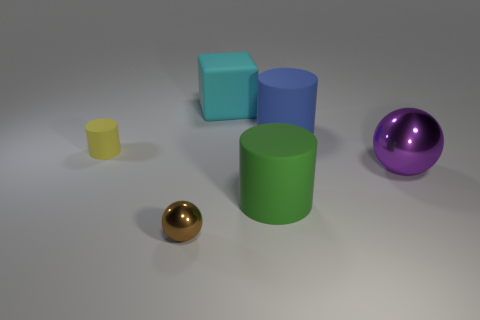How many cyan things are large rubber cylinders or tiny objects?
Keep it short and to the point. 0. Do the big sphere that is in front of the yellow rubber cylinder and the tiny cylinder have the same material?
Offer a very short reply. No. How many other objects are the same material as the big purple object?
Ensure brevity in your answer.  1. What material is the purple sphere?
Your response must be concise. Metal. There is a cylinder in front of the big purple metal ball; what size is it?
Provide a short and direct response. Large. There is a cylinder that is behind the tiny yellow matte object; how many big cylinders are in front of it?
Keep it short and to the point. 1. Does the tiny object in front of the large sphere have the same shape as the thing that is to the right of the blue cylinder?
Keep it short and to the point. Yes. How many objects are on the right side of the cyan block and in front of the purple sphere?
Your response must be concise. 1. Are there any large things of the same color as the large block?
Your answer should be compact. No. What shape is the cyan matte object that is the same size as the purple metal ball?
Keep it short and to the point. Cube. 